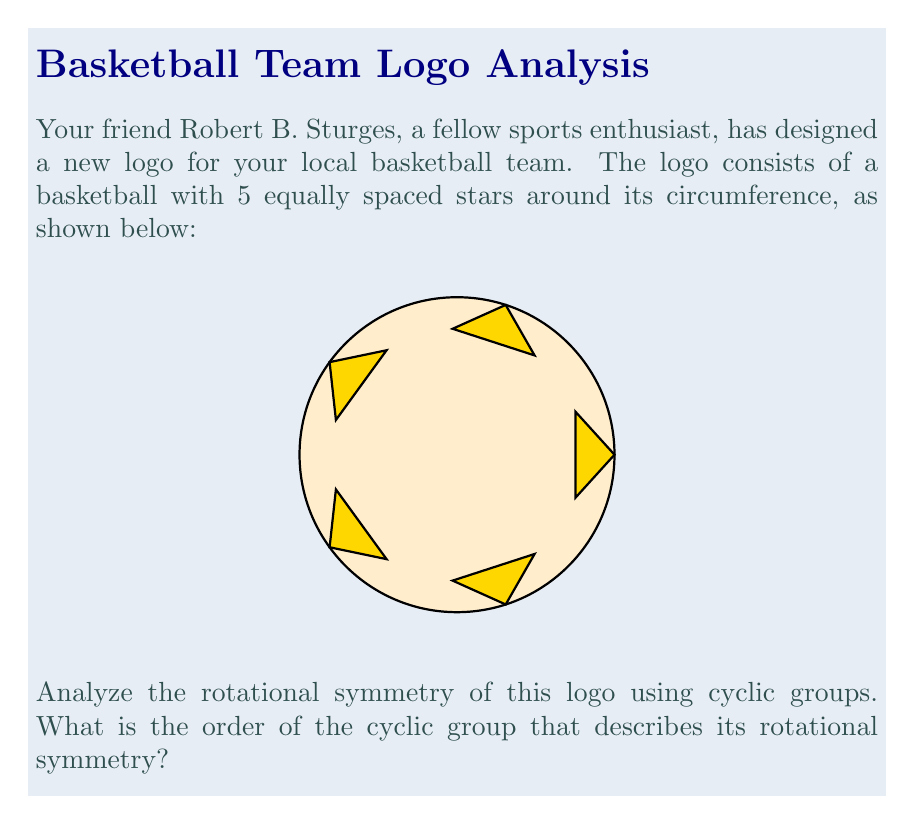What is the answer to this math problem? To analyze the rotational symmetry of this logo using cyclic groups, we need to follow these steps:

1) First, we need to identify all the distinct rotations that bring the logo back to its original position. 

2) In this case, we can rotate the logo by multiples of 72° (or 2π/5 radians) to achieve this. The possible rotations are:
   - 0° (identity rotation)
   - 72° (2π/5 radians)
   - 144° (4π/5 radians)
   - 216° (6π/5 radians)
   - 288° (8π/5 radians)

3) These rotations form a cyclic group under composition. Let's call this group G.

4) The elements of G can be represented as powers of a single rotation r:
   G = {e, r, r², r³, r⁴}
   where e is the identity element (0° rotation) and r is the 72° rotation.

5) We can verify that this set satisfies the group axioms:
   - Closure: Composing any two rotations results in another rotation in the set.
   - Associativity: Rotation compositions are always associative.
   - Identity: The 0° rotation (e) is the identity element.
   - Inverse: Each rotation has an inverse in the set (e.g., r⁴ is the inverse of r).

6) The order of a cyclic group is the number of distinct elements it contains.

7) In this case, we have 5 distinct rotations, so the order of the cyclic group is 5.

Therefore, the rotational symmetry of this logo can be described by the cyclic group C₅, which has order 5.
Answer: 5 